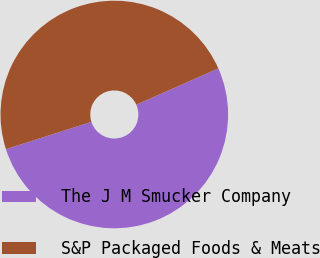Convert chart. <chart><loc_0><loc_0><loc_500><loc_500><pie_chart><fcel>The J M Smucker Company<fcel>S&P Packaged Foods & Meats<nl><fcel>51.71%<fcel>48.29%<nl></chart> 